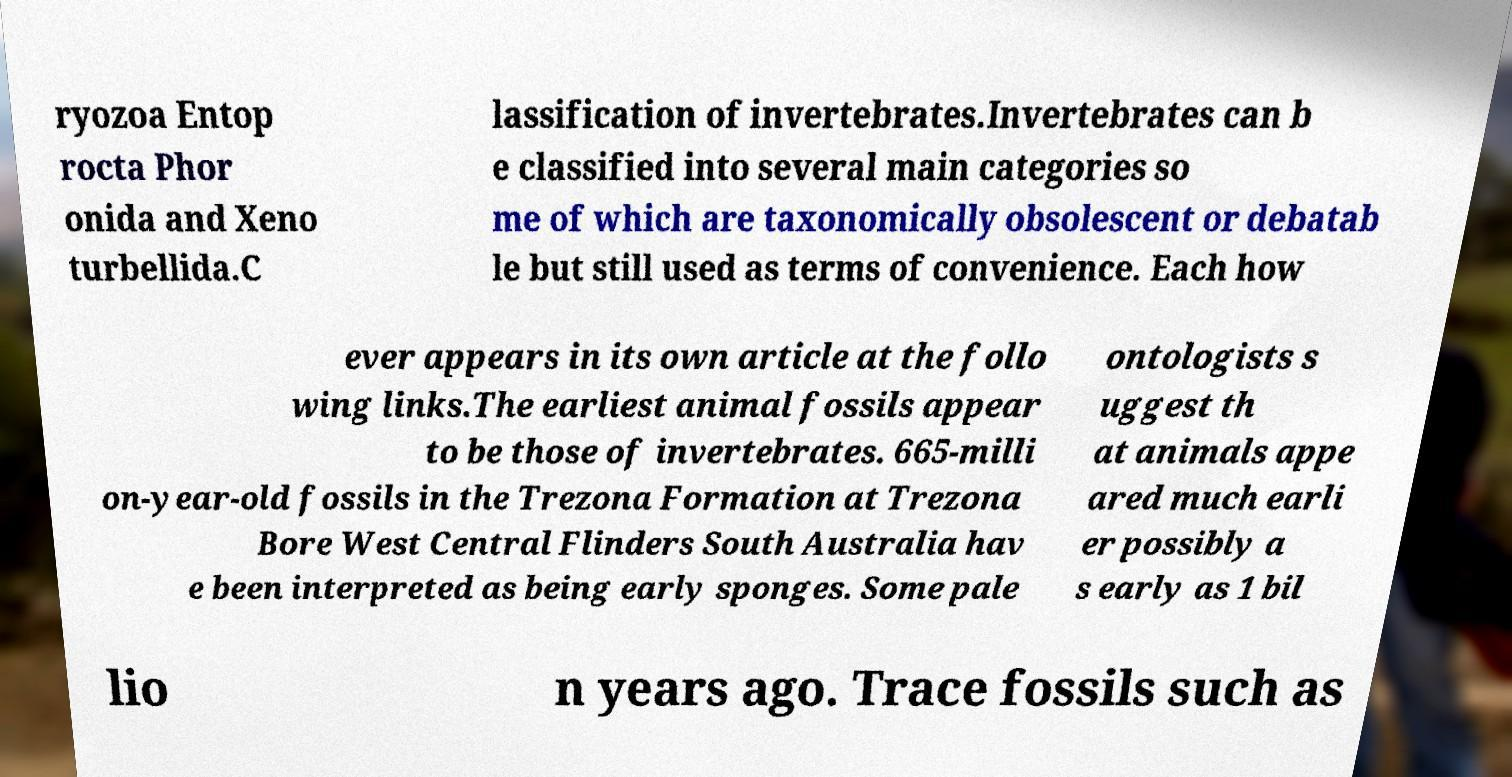There's text embedded in this image that I need extracted. Can you transcribe it verbatim? ryozoa Entop rocta Phor onida and Xeno turbellida.C lassification of invertebrates.Invertebrates can b e classified into several main categories so me of which are taxonomically obsolescent or debatab le but still used as terms of convenience. Each how ever appears in its own article at the follo wing links.The earliest animal fossils appear to be those of invertebrates. 665-milli on-year-old fossils in the Trezona Formation at Trezona Bore West Central Flinders South Australia hav e been interpreted as being early sponges. Some pale ontologists s uggest th at animals appe ared much earli er possibly a s early as 1 bil lio n years ago. Trace fossils such as 